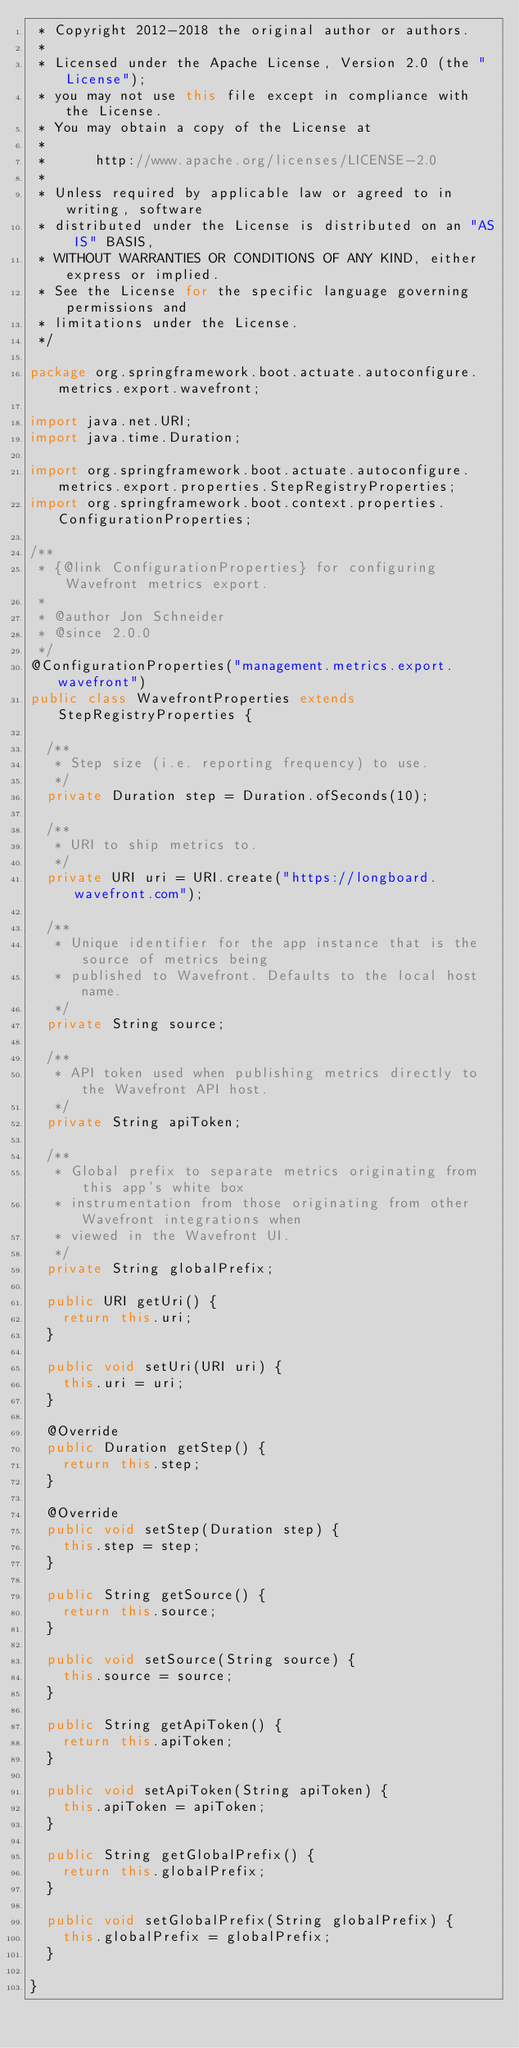<code> <loc_0><loc_0><loc_500><loc_500><_Java_> * Copyright 2012-2018 the original author or authors.
 *
 * Licensed under the Apache License, Version 2.0 (the "License");
 * you may not use this file except in compliance with the License.
 * You may obtain a copy of the License at
 *
 *      http://www.apache.org/licenses/LICENSE-2.0
 *
 * Unless required by applicable law or agreed to in writing, software
 * distributed under the License is distributed on an "AS IS" BASIS,
 * WITHOUT WARRANTIES OR CONDITIONS OF ANY KIND, either express or implied.
 * See the License for the specific language governing permissions and
 * limitations under the License.
 */

package org.springframework.boot.actuate.autoconfigure.metrics.export.wavefront;

import java.net.URI;
import java.time.Duration;

import org.springframework.boot.actuate.autoconfigure.metrics.export.properties.StepRegistryProperties;
import org.springframework.boot.context.properties.ConfigurationProperties;

/**
 * {@link ConfigurationProperties} for configuring Wavefront metrics export.
 *
 * @author Jon Schneider
 * @since 2.0.0
 */
@ConfigurationProperties("management.metrics.export.wavefront")
public class WavefrontProperties extends StepRegistryProperties {

	/**
	 * Step size (i.e. reporting frequency) to use.
	 */
	private Duration step = Duration.ofSeconds(10);

	/**
	 * URI to ship metrics to.
	 */
	private URI uri = URI.create("https://longboard.wavefront.com");

	/**
	 * Unique identifier for the app instance that is the source of metrics being
	 * published to Wavefront. Defaults to the local host name.
	 */
	private String source;

	/**
	 * API token used when publishing metrics directly to the Wavefront API host.
	 */
	private String apiToken;

	/**
	 * Global prefix to separate metrics originating from this app's white box
	 * instrumentation from those originating from other Wavefront integrations when
	 * viewed in the Wavefront UI.
	 */
	private String globalPrefix;

	public URI getUri() {
		return this.uri;
	}

	public void setUri(URI uri) {
		this.uri = uri;
	}

	@Override
	public Duration getStep() {
		return this.step;
	}

	@Override
	public void setStep(Duration step) {
		this.step = step;
	}

	public String getSource() {
		return this.source;
	}

	public void setSource(String source) {
		this.source = source;
	}

	public String getApiToken() {
		return this.apiToken;
	}

	public void setApiToken(String apiToken) {
		this.apiToken = apiToken;
	}

	public String getGlobalPrefix() {
		return this.globalPrefix;
	}

	public void setGlobalPrefix(String globalPrefix) {
		this.globalPrefix = globalPrefix;
	}

}
</code> 